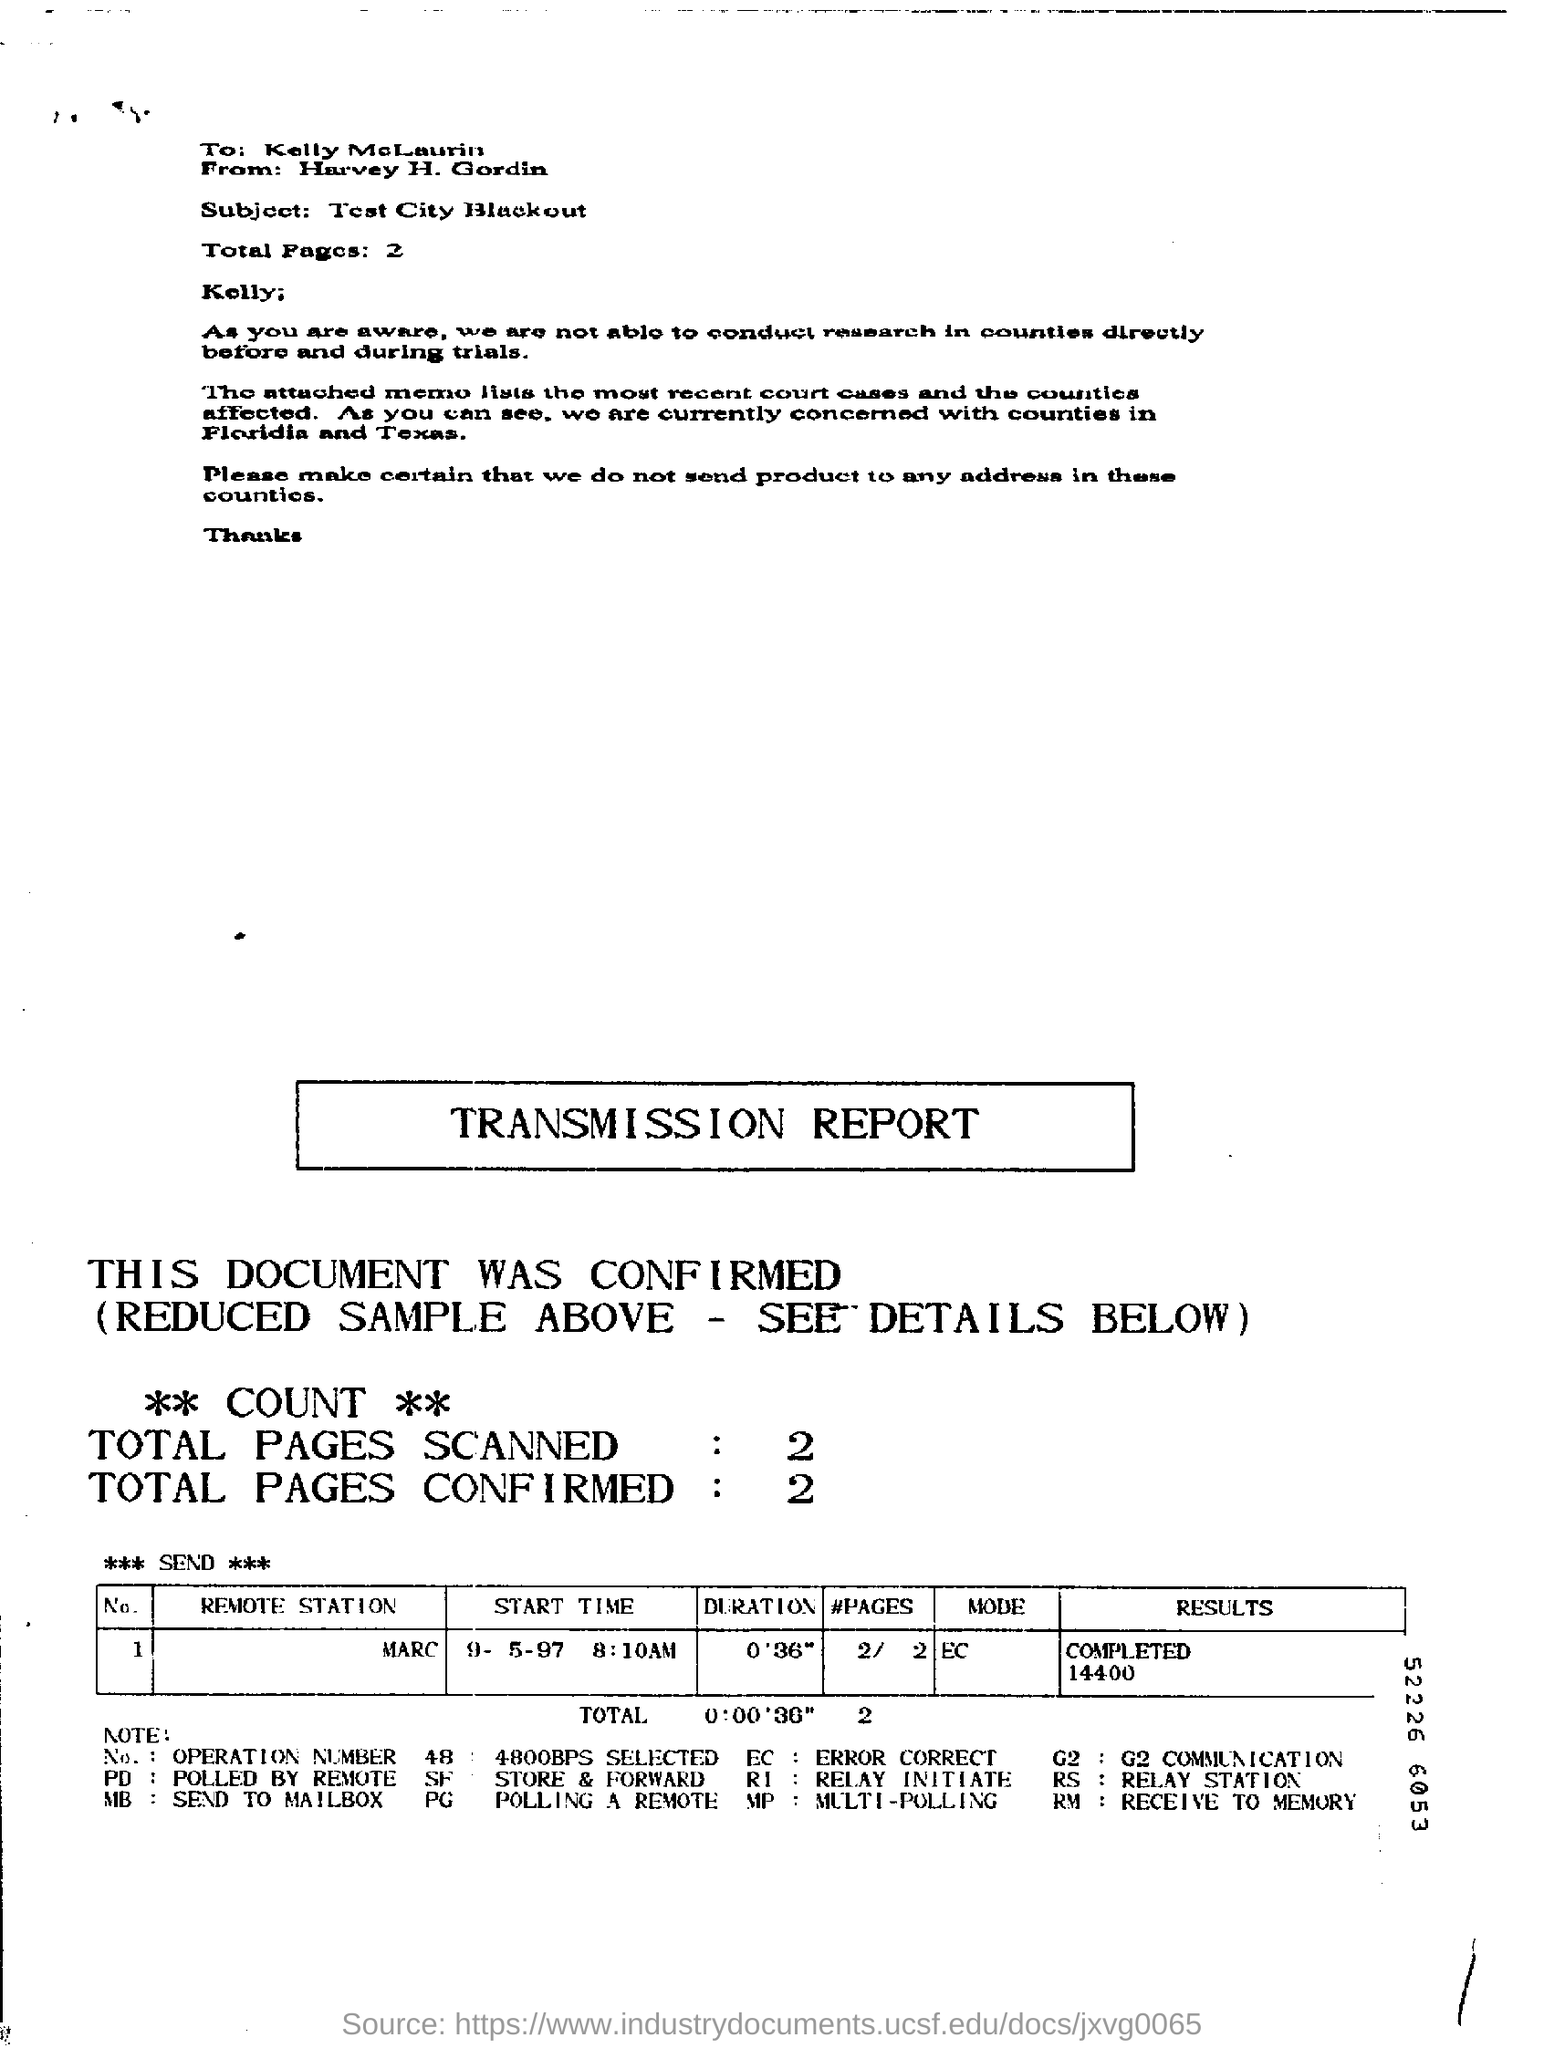What is the total number of pages ?
Offer a very short reply. 2. Whom is this written from ?
Your answer should be compact. Harvey H. Gordin. Whom is this written to ?
Your answer should be very brief. Kelly mclaurin. How many total pages are scanned ?
Make the answer very short. 2. How many total pages are confirmed ?
Give a very brief answer. 2. What is the name of the remote station ?
Offer a very short reply. Marc. 